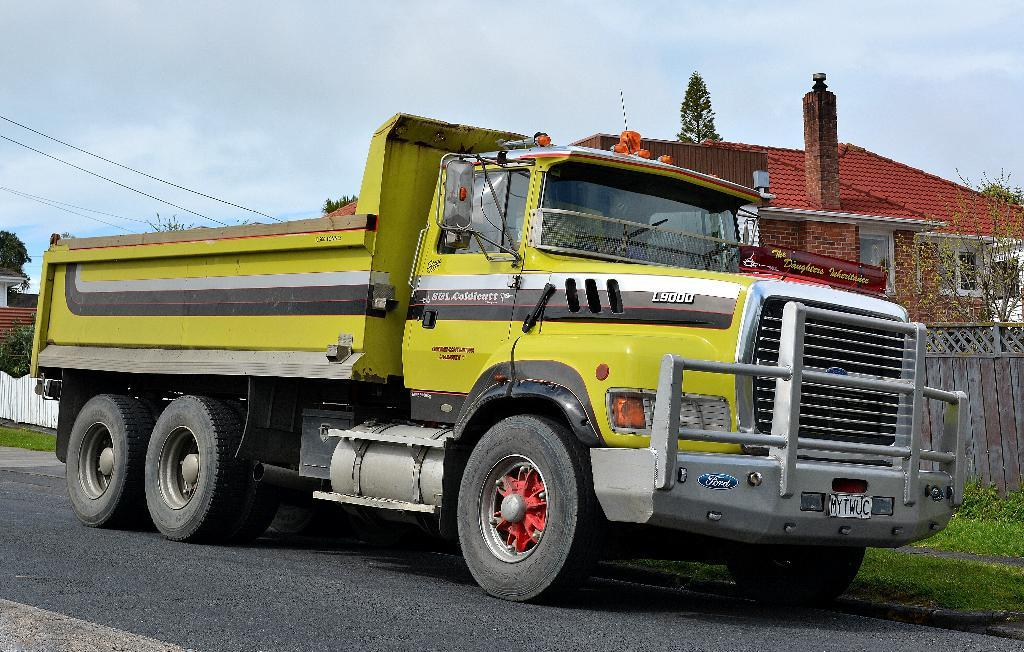What type of vehicle is on the road in the image? There is a truck on the road in the image. What type of vegetation can be seen in the image? There is grass and trees visible in the image. What type of structure is in the image? There is a house with a roof and windows in the image. What other objects can be seen in the image? There is a fence, wires, and the sky is visible in the image. What type of stocking is hanging on the fence in the image? There is no stocking present in the image. How does the elbow of the truck driver look like in the image? There is no truck driver visible in the image, so it is not possible to see their elbow. 